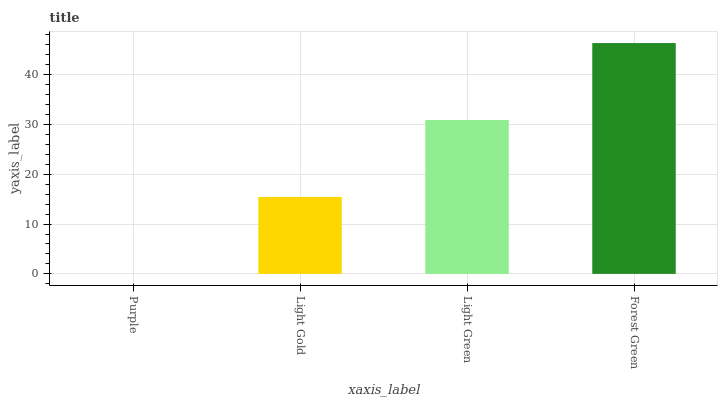Is Purple the minimum?
Answer yes or no. Yes. Is Forest Green the maximum?
Answer yes or no. Yes. Is Light Gold the minimum?
Answer yes or no. No. Is Light Gold the maximum?
Answer yes or no. No. Is Light Gold greater than Purple?
Answer yes or no. Yes. Is Purple less than Light Gold?
Answer yes or no. Yes. Is Purple greater than Light Gold?
Answer yes or no. No. Is Light Gold less than Purple?
Answer yes or no. No. Is Light Green the high median?
Answer yes or no. Yes. Is Light Gold the low median?
Answer yes or no. Yes. Is Forest Green the high median?
Answer yes or no. No. Is Forest Green the low median?
Answer yes or no. No. 